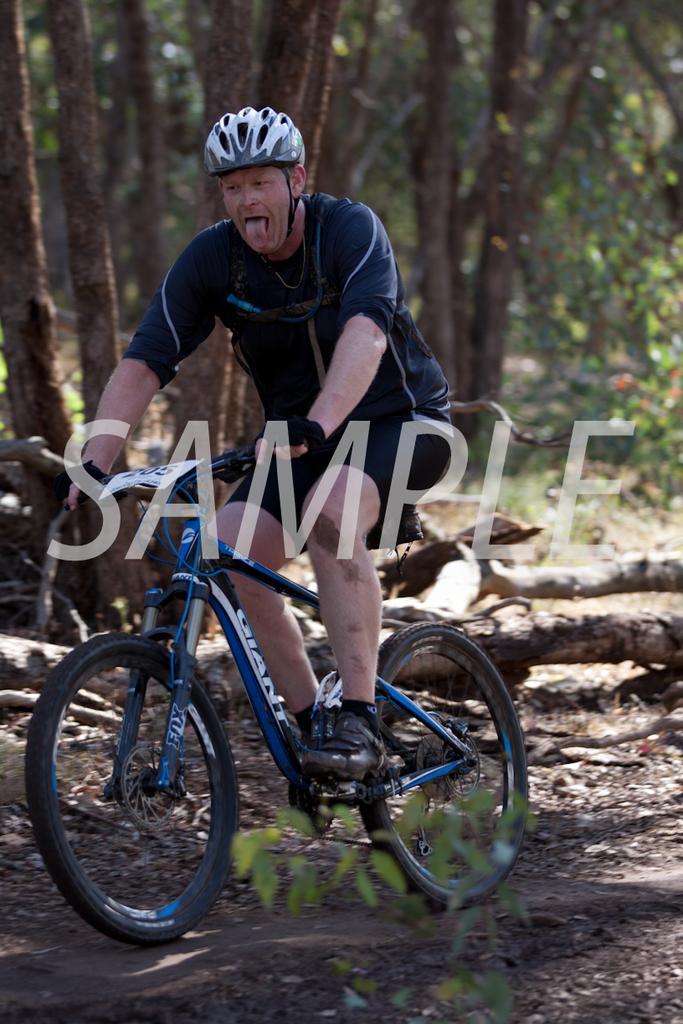Can you describe this image briefly? In this picture I can observe a man cycling a bicycle in the middle of the picture. He is wearing helmet. In the background there are some trees. I can observe watermark in the middle of the picture. 